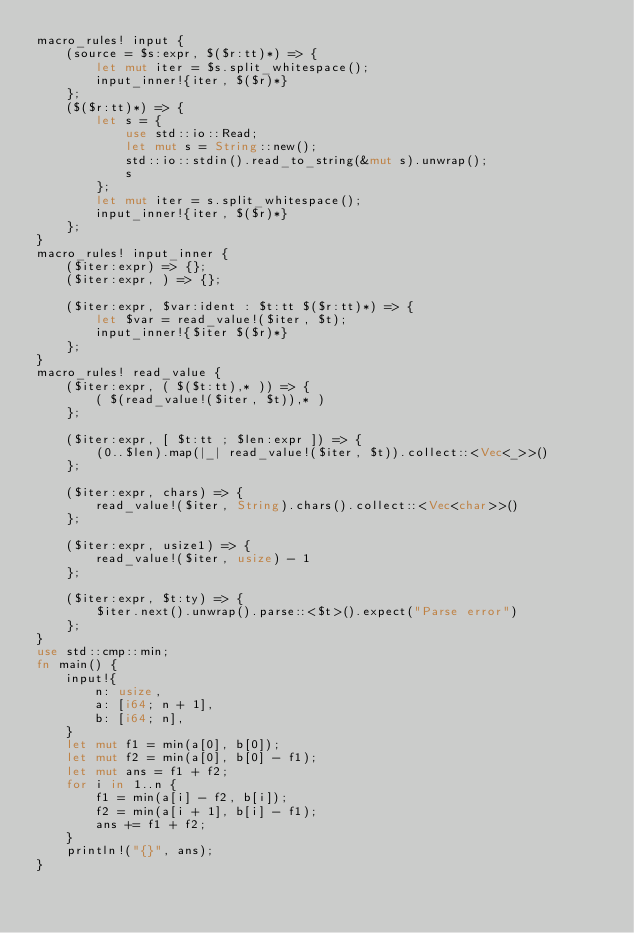<code> <loc_0><loc_0><loc_500><loc_500><_Rust_>macro_rules! input {
    (source = $s:expr, $($r:tt)*) => {
        let mut iter = $s.split_whitespace();
        input_inner!{iter, $($r)*}
    };
    ($($r:tt)*) => {
        let s = {
            use std::io::Read;
            let mut s = String::new();
            std::io::stdin().read_to_string(&mut s).unwrap();
            s
        };
        let mut iter = s.split_whitespace();
        input_inner!{iter, $($r)*}
    };
}
macro_rules! input_inner {
    ($iter:expr) => {};
    ($iter:expr, ) => {};

    ($iter:expr, $var:ident : $t:tt $($r:tt)*) => {
        let $var = read_value!($iter, $t);
        input_inner!{$iter $($r)*}
    };
}
macro_rules! read_value {
    ($iter:expr, ( $($t:tt),* )) => {
        ( $(read_value!($iter, $t)),* )
    };

    ($iter:expr, [ $t:tt ; $len:expr ]) => {
        (0..$len).map(|_| read_value!($iter, $t)).collect::<Vec<_>>()
    };

    ($iter:expr, chars) => {
        read_value!($iter, String).chars().collect::<Vec<char>>()
    };

    ($iter:expr, usize1) => {
        read_value!($iter, usize) - 1
    };

    ($iter:expr, $t:ty) => {
        $iter.next().unwrap().parse::<$t>().expect("Parse error")
    };
}
use std::cmp::min;
fn main() {
    input!{
        n: usize,
        a: [i64; n + 1],
        b: [i64; n],
    }
    let mut f1 = min(a[0], b[0]);
    let mut f2 = min(a[0], b[0] - f1);
    let mut ans = f1 + f2;
    for i in 1..n {
        f1 = min(a[i] - f2, b[i]);
        f2 = min(a[i + 1], b[i] - f1);
        ans += f1 + f2;
    }
    println!("{}", ans);
}
</code> 